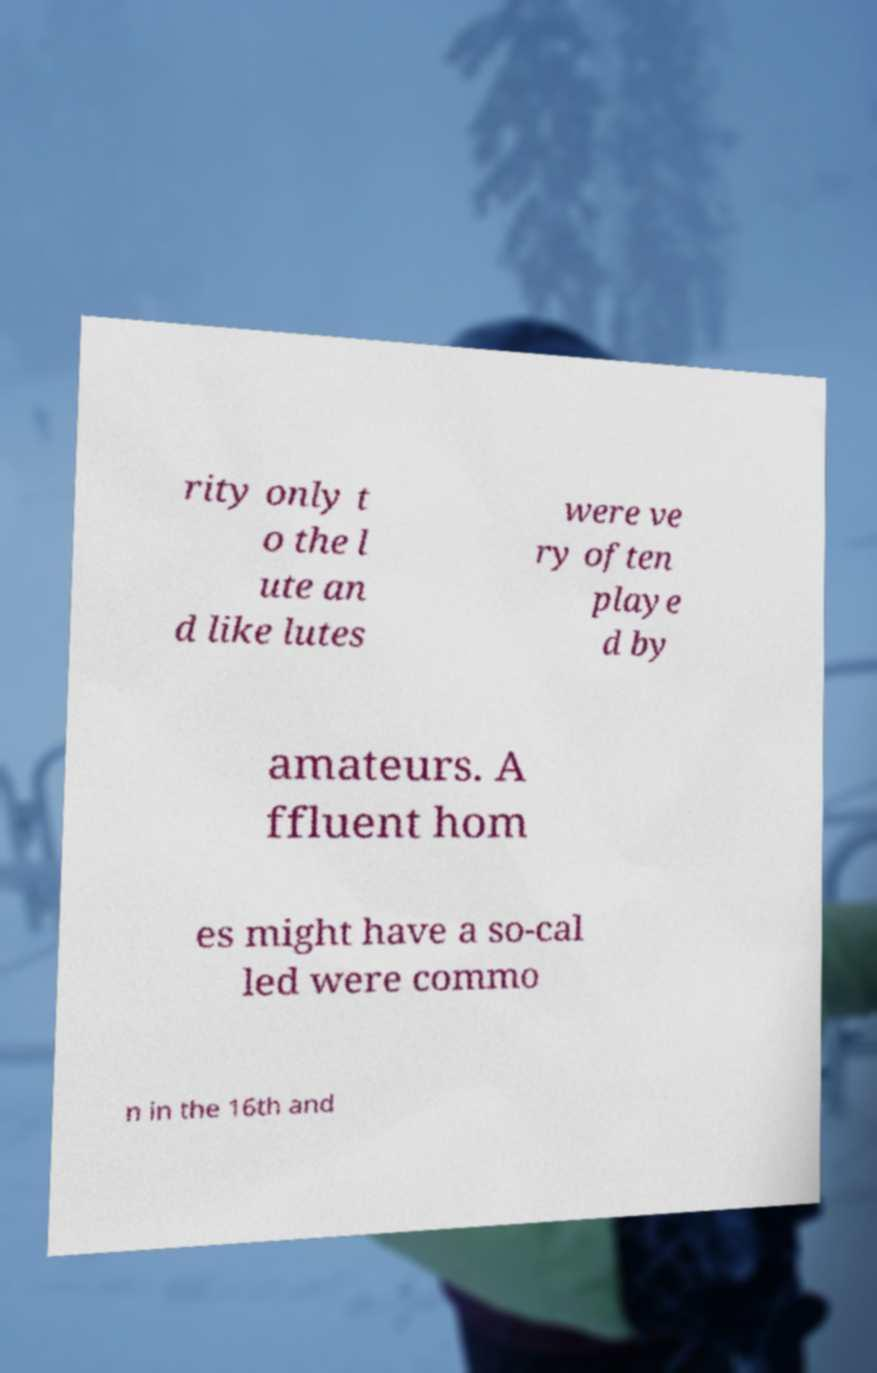Could you assist in decoding the text presented in this image and type it out clearly? rity only t o the l ute an d like lutes were ve ry often playe d by amateurs. A ffluent hom es might have a so-cal led were commo n in the 16th and 